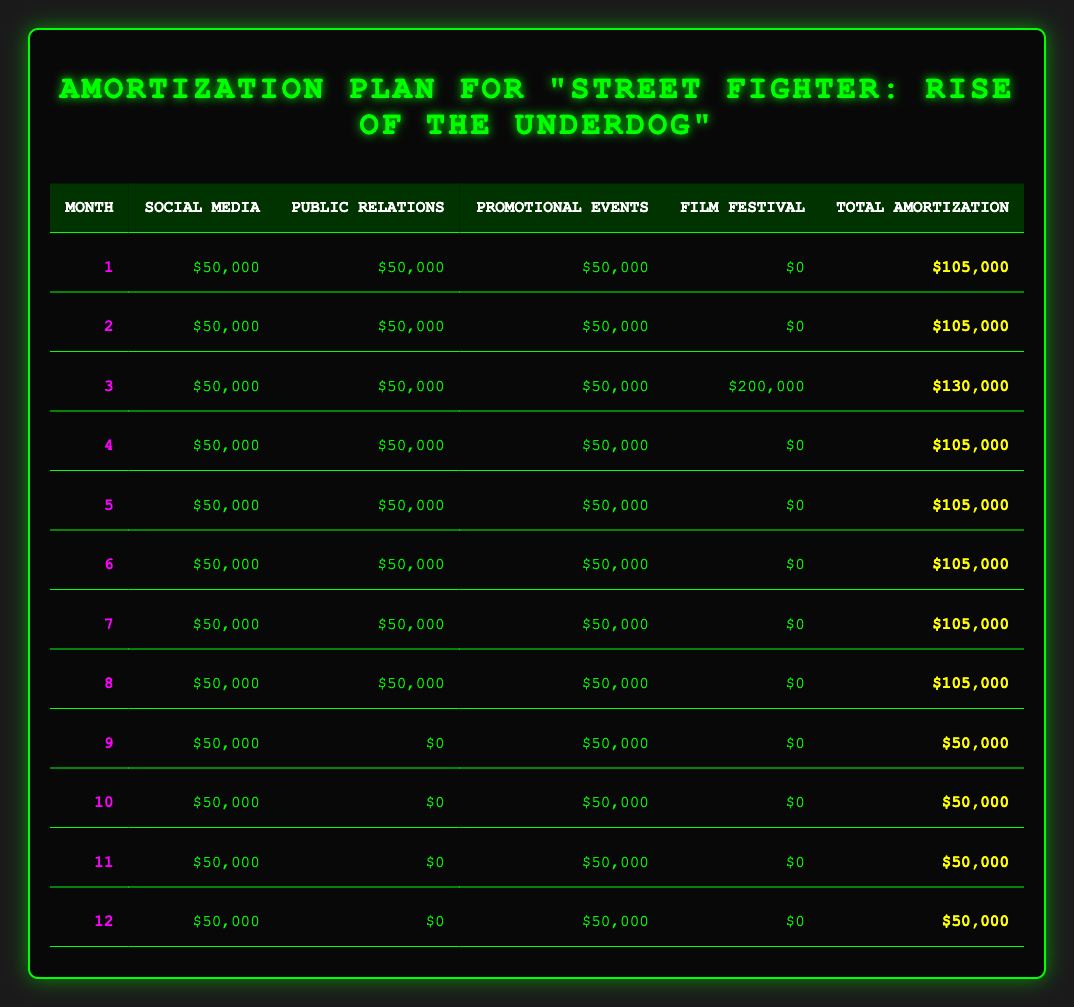What is the total amortization for the first month? In the first month, the total amortization is listed in the table as $105,000. This value is found directly in the corresponding cell for month 1.
Answer: 105,000 What was the total marketing expense for 'Public Relations'? The total marketing expense for Public Relations is $300,000, which is provided in the expense details section of the plan.
Answer: 300,000 Which month had the highest total amortization, and how much was it? The highest total amortization occurred in month 3, where the total is shown as $130,000. This is due to the additional film festival expense recorded during that month.
Answer: Month 3, 130,000 What is the average monthly amortization amount over the 12 months? To find the average monthly amortization, you sum the total amortizations for all 12 months and then divide by 12. The total from the table is $1,155,000 (105,000 * 8 + 130,000 + 50,000 * 3), leading to an average of $1,155,000 / 12 = $96,250.
Answer: 96,250 Is there any month where there were expenses for 'Film Festival Screenings' other than month 3? No, month 3 is the only month that shows an expense for Film Festival Screenings, which is $200,000. All other months have this expense listed as $0.
Answer: No What is the combined total amortization for Social Media Advertising and Promotional Events in month 4? In month 4, the amortization for Social Media Advertising is $50,000 and for Promotional Events, it is also $50,000. The combined total is $50,000 + $50,000 = $100,000.
Answer: 100,000 In how many months was there no spending on Public Relations? Public Relations spending was recorded for 6 months (months 1 through 6), meaning there were 6 months (months 7 through 12) with no spending.
Answer: 6 What is the total amortization amount for months 9 to 12? The total amortization for months 9 to 12 is calculated as follows: month 9 = 50,000, month 10 = 50,000, month 11 = 50,000, and month 12 = 50,000. Therefore, the total is 50,000 * 4 = 200,000.
Answer: 200,000 What percentage of the total marketing budget is allocated to Social Media Advertising? The total budget for marketing is $1,500,000, and Social Media Advertising has a budget of $600,000. To find the percentage, use the formula (600,000 / 1,500,000) * 100 = 40%.
Answer: 40% 